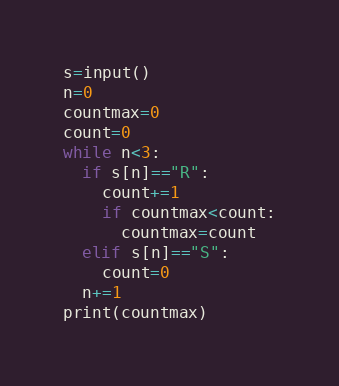<code> <loc_0><loc_0><loc_500><loc_500><_Python_>s=input()
n=0
countmax=0
count=0
while n<3:
  if s[n]=="R":
    count+=1
    if countmax<count:
      countmax=count
  elif s[n]=="S":
    count=0
  n+=1
print(countmax)</code> 